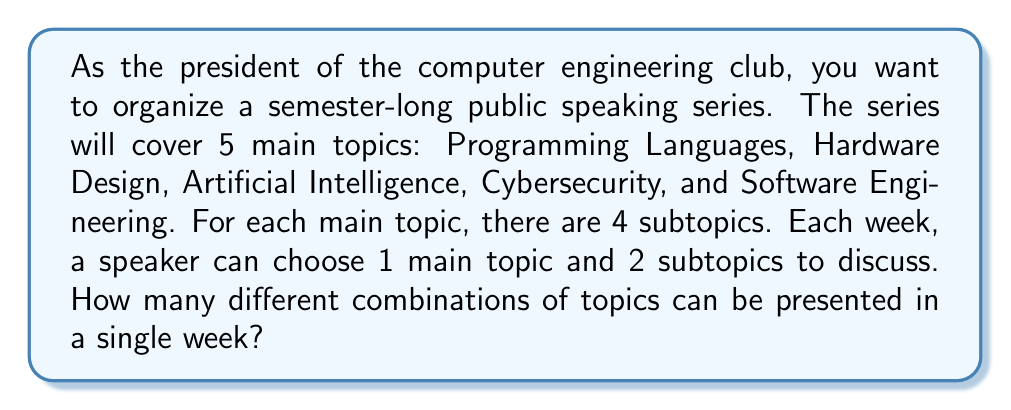Could you help me with this problem? Let's break this down step-by-step:

1) First, we need to choose the main topic:
   There are 5 main topics to choose from, so we have 5 choices.

2) After selecting the main topic, we need to choose 2 subtopics from the 4 available for that main topic:
   This is a combination problem, as the order doesn't matter.
   We can represent this as $\binom{4}{2}$ or "4 choose 2".

3) The formula for this combination is:
   $$\binom{4}{2} = \frac{4!}{2!(4-2)!} = \frac{4!}{2!2!} = \frac{4 \cdot 3}{2 \cdot 1} = 6$$

4) Now, for each main topic, we have 6 ways to choose the subtopics.

5) To get the total number of combinations, we multiply the number of choices for the main topic by the number of ways to choose the subtopics:

   $$5 \cdot 6 = 30$$

Therefore, there are 30 different combinations of topics that can be presented in a single week.
Answer: 30 